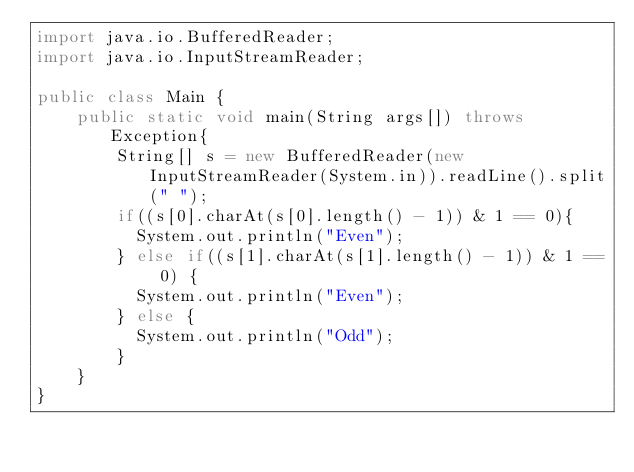Convert code to text. <code><loc_0><loc_0><loc_500><loc_500><_Java_>import java.io.BufferedReader;
import java.io.InputStreamReader;
 
public class Main {
    public static void main(String args[]) throws Exception{
        String[] s = new BufferedReader(new InputStreamReader(System.in)).readLine().split(" ");
        if((s[0].charAt(s[0].length() - 1)) & 1 == 0){
          System.out.println("Even");
        } else if((s[1].charAt(s[1].length() - 1)) & 1 == 0) {
          System.out.println("Even");
        } else {
          System.out.println("Odd");
        }
    }
}</code> 